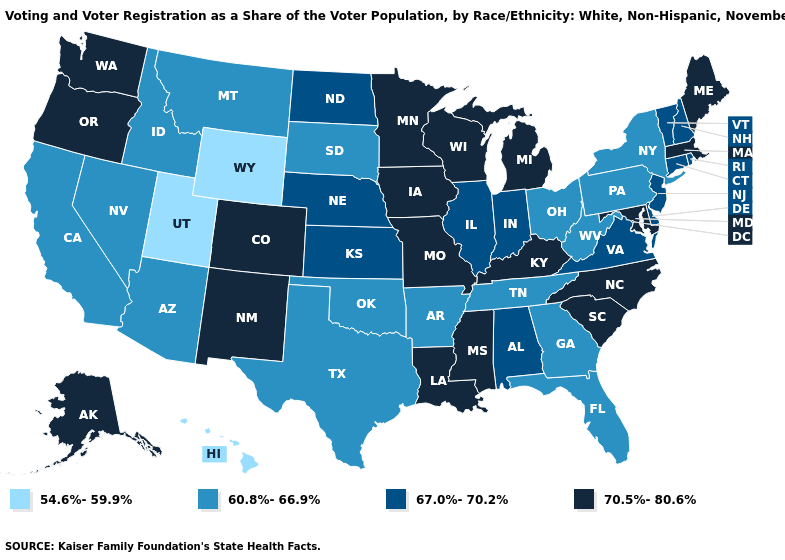What is the highest value in the South ?
Concise answer only. 70.5%-80.6%. Is the legend a continuous bar?
Quick response, please. No. Among the states that border Nevada , which have the lowest value?
Quick response, please. Utah. Name the states that have a value in the range 70.5%-80.6%?
Concise answer only. Alaska, Colorado, Iowa, Kentucky, Louisiana, Maine, Maryland, Massachusetts, Michigan, Minnesota, Mississippi, Missouri, New Mexico, North Carolina, Oregon, South Carolina, Washington, Wisconsin. Name the states that have a value in the range 67.0%-70.2%?
Answer briefly. Alabama, Connecticut, Delaware, Illinois, Indiana, Kansas, Nebraska, New Hampshire, New Jersey, North Dakota, Rhode Island, Vermont, Virginia. What is the lowest value in states that border Connecticut?
Write a very short answer. 60.8%-66.9%. What is the value of Alabama?
Be succinct. 67.0%-70.2%. Name the states that have a value in the range 60.8%-66.9%?
Answer briefly. Arizona, Arkansas, California, Florida, Georgia, Idaho, Montana, Nevada, New York, Ohio, Oklahoma, Pennsylvania, South Dakota, Tennessee, Texas, West Virginia. Does Connecticut have a higher value than California?
Give a very brief answer. Yes. What is the value of Vermont?
Write a very short answer. 67.0%-70.2%. Among the states that border New Hampshire , which have the highest value?
Concise answer only. Maine, Massachusetts. Does Michigan have a lower value than Montana?
Write a very short answer. No. What is the value of Missouri?
Give a very brief answer. 70.5%-80.6%. Name the states that have a value in the range 67.0%-70.2%?
Answer briefly. Alabama, Connecticut, Delaware, Illinois, Indiana, Kansas, Nebraska, New Hampshire, New Jersey, North Dakota, Rhode Island, Vermont, Virginia. Which states have the lowest value in the USA?
Be succinct. Hawaii, Utah, Wyoming. 